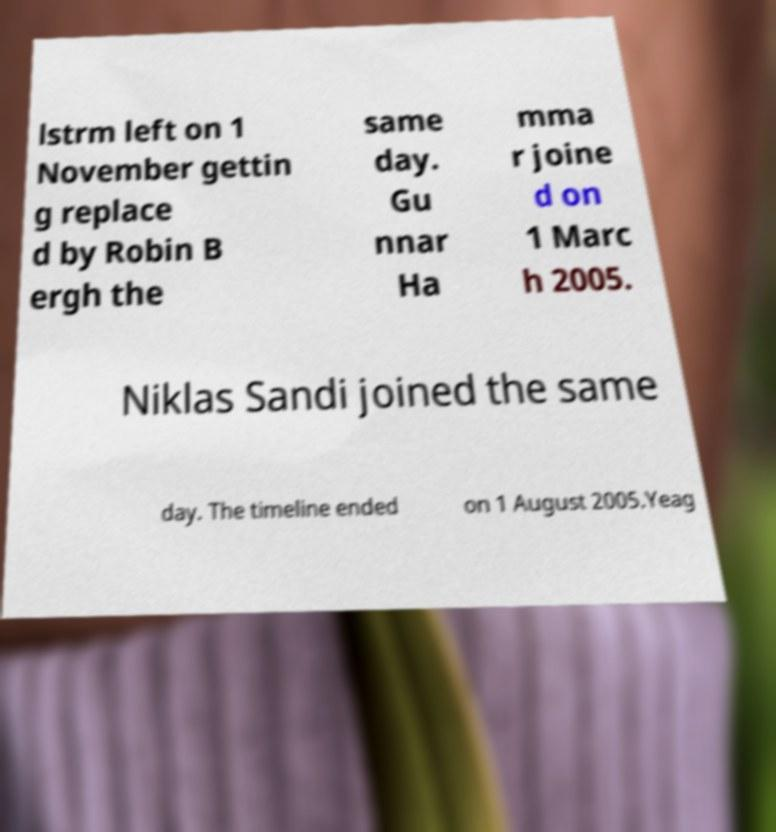Can you accurately transcribe the text from the provided image for me? lstrm left on 1 November gettin g replace d by Robin B ergh the same day. Gu nnar Ha mma r joine d on 1 Marc h 2005. Niklas Sandi joined the same day. The timeline ended on 1 August 2005.Yeag 